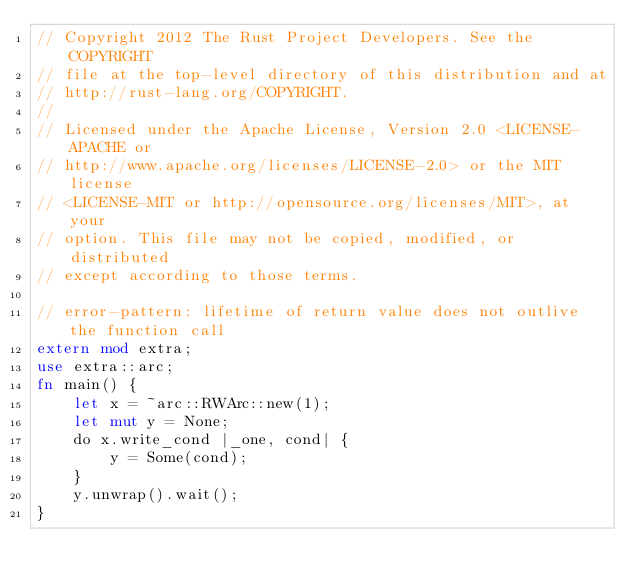Convert code to text. <code><loc_0><loc_0><loc_500><loc_500><_Rust_>// Copyright 2012 The Rust Project Developers. See the COPYRIGHT
// file at the top-level directory of this distribution and at
// http://rust-lang.org/COPYRIGHT.
//
// Licensed under the Apache License, Version 2.0 <LICENSE-APACHE or
// http://www.apache.org/licenses/LICENSE-2.0> or the MIT license
// <LICENSE-MIT or http://opensource.org/licenses/MIT>, at your
// option. This file may not be copied, modified, or distributed
// except according to those terms.

// error-pattern: lifetime of return value does not outlive the function call
extern mod extra;
use extra::arc;
fn main() {
    let x = ~arc::RWArc::new(1);
    let mut y = None;
    do x.write_cond |_one, cond| {
        y = Some(cond);
    }
    y.unwrap().wait();
}
</code> 